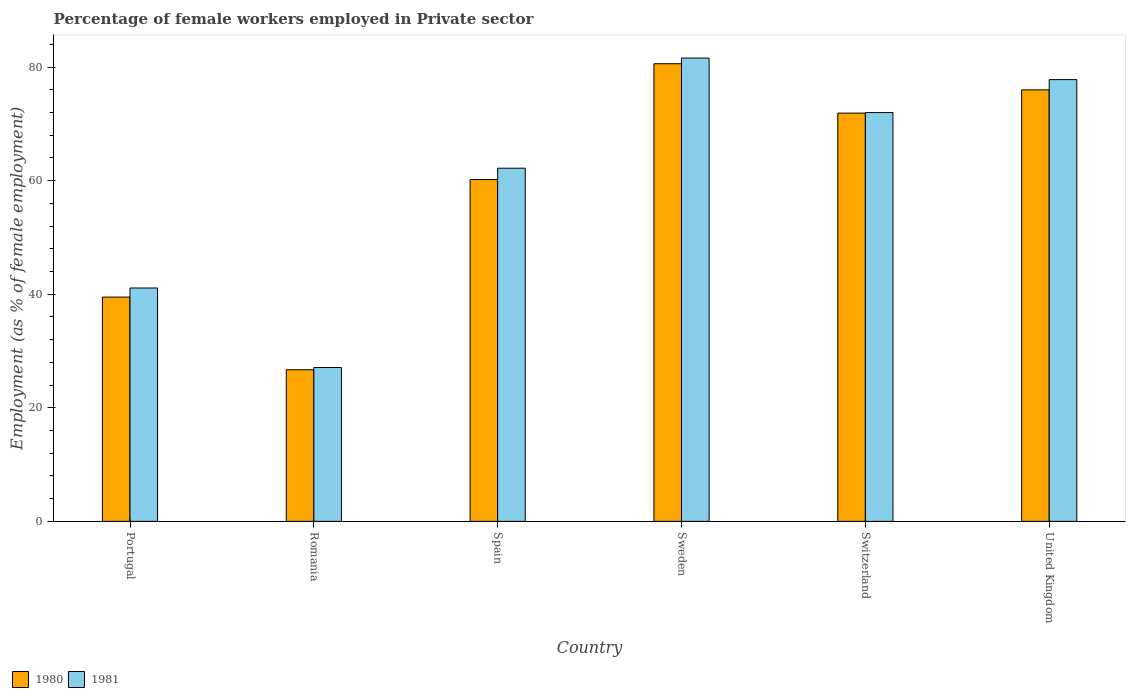How many different coloured bars are there?
Your answer should be very brief. 2. How many groups of bars are there?
Provide a succinct answer. 6. What is the label of the 6th group of bars from the left?
Give a very brief answer. United Kingdom. What is the percentage of females employed in Private sector in 1980 in Romania?
Keep it short and to the point. 26.7. Across all countries, what is the maximum percentage of females employed in Private sector in 1980?
Keep it short and to the point. 80.6. Across all countries, what is the minimum percentage of females employed in Private sector in 1981?
Ensure brevity in your answer.  27.1. In which country was the percentage of females employed in Private sector in 1981 maximum?
Ensure brevity in your answer.  Sweden. In which country was the percentage of females employed in Private sector in 1980 minimum?
Give a very brief answer. Romania. What is the total percentage of females employed in Private sector in 1981 in the graph?
Give a very brief answer. 361.8. What is the difference between the percentage of females employed in Private sector in 1981 in Romania and that in Switzerland?
Make the answer very short. -44.9. What is the difference between the percentage of females employed in Private sector in 1980 in Sweden and the percentage of females employed in Private sector in 1981 in United Kingdom?
Keep it short and to the point. 2.8. What is the average percentage of females employed in Private sector in 1980 per country?
Give a very brief answer. 59.15. What is the difference between the percentage of females employed in Private sector of/in 1981 and percentage of females employed in Private sector of/in 1980 in Switzerland?
Ensure brevity in your answer.  0.1. What is the ratio of the percentage of females employed in Private sector in 1981 in Portugal to that in Romania?
Keep it short and to the point. 1.52. What is the difference between the highest and the second highest percentage of females employed in Private sector in 1981?
Your answer should be very brief. -9.6. What is the difference between the highest and the lowest percentage of females employed in Private sector in 1981?
Give a very brief answer. 54.5. In how many countries, is the percentage of females employed in Private sector in 1981 greater than the average percentage of females employed in Private sector in 1981 taken over all countries?
Your response must be concise. 4. Is the sum of the percentage of females employed in Private sector in 1980 in Portugal and Romania greater than the maximum percentage of females employed in Private sector in 1981 across all countries?
Your answer should be compact. No. What does the 2nd bar from the left in Portugal represents?
Offer a very short reply. 1981. What does the 1st bar from the right in Spain represents?
Make the answer very short. 1981. Are the values on the major ticks of Y-axis written in scientific E-notation?
Give a very brief answer. No. Where does the legend appear in the graph?
Keep it short and to the point. Bottom left. What is the title of the graph?
Keep it short and to the point. Percentage of female workers employed in Private sector. What is the label or title of the Y-axis?
Offer a very short reply. Employment (as % of female employment). What is the Employment (as % of female employment) in 1980 in Portugal?
Offer a terse response. 39.5. What is the Employment (as % of female employment) in 1981 in Portugal?
Offer a terse response. 41.1. What is the Employment (as % of female employment) in 1980 in Romania?
Provide a succinct answer. 26.7. What is the Employment (as % of female employment) of 1981 in Romania?
Give a very brief answer. 27.1. What is the Employment (as % of female employment) of 1980 in Spain?
Your answer should be compact. 60.2. What is the Employment (as % of female employment) of 1981 in Spain?
Provide a short and direct response. 62.2. What is the Employment (as % of female employment) in 1980 in Sweden?
Your answer should be compact. 80.6. What is the Employment (as % of female employment) in 1981 in Sweden?
Your response must be concise. 81.6. What is the Employment (as % of female employment) in 1980 in Switzerland?
Ensure brevity in your answer.  71.9. What is the Employment (as % of female employment) in 1981 in Switzerland?
Make the answer very short. 72. What is the Employment (as % of female employment) in 1981 in United Kingdom?
Offer a very short reply. 77.8. Across all countries, what is the maximum Employment (as % of female employment) in 1980?
Your answer should be compact. 80.6. Across all countries, what is the maximum Employment (as % of female employment) of 1981?
Offer a very short reply. 81.6. Across all countries, what is the minimum Employment (as % of female employment) of 1980?
Your response must be concise. 26.7. Across all countries, what is the minimum Employment (as % of female employment) in 1981?
Make the answer very short. 27.1. What is the total Employment (as % of female employment) in 1980 in the graph?
Provide a short and direct response. 354.9. What is the total Employment (as % of female employment) in 1981 in the graph?
Ensure brevity in your answer.  361.8. What is the difference between the Employment (as % of female employment) of 1980 in Portugal and that in Romania?
Your answer should be compact. 12.8. What is the difference between the Employment (as % of female employment) of 1981 in Portugal and that in Romania?
Give a very brief answer. 14. What is the difference between the Employment (as % of female employment) of 1980 in Portugal and that in Spain?
Ensure brevity in your answer.  -20.7. What is the difference between the Employment (as % of female employment) of 1981 in Portugal and that in Spain?
Your answer should be compact. -21.1. What is the difference between the Employment (as % of female employment) of 1980 in Portugal and that in Sweden?
Ensure brevity in your answer.  -41.1. What is the difference between the Employment (as % of female employment) in 1981 in Portugal and that in Sweden?
Provide a succinct answer. -40.5. What is the difference between the Employment (as % of female employment) of 1980 in Portugal and that in Switzerland?
Give a very brief answer. -32.4. What is the difference between the Employment (as % of female employment) in 1981 in Portugal and that in Switzerland?
Offer a terse response. -30.9. What is the difference between the Employment (as % of female employment) in 1980 in Portugal and that in United Kingdom?
Give a very brief answer. -36.5. What is the difference between the Employment (as % of female employment) of 1981 in Portugal and that in United Kingdom?
Offer a terse response. -36.7. What is the difference between the Employment (as % of female employment) of 1980 in Romania and that in Spain?
Ensure brevity in your answer.  -33.5. What is the difference between the Employment (as % of female employment) in 1981 in Romania and that in Spain?
Give a very brief answer. -35.1. What is the difference between the Employment (as % of female employment) in 1980 in Romania and that in Sweden?
Provide a short and direct response. -53.9. What is the difference between the Employment (as % of female employment) in 1981 in Romania and that in Sweden?
Offer a terse response. -54.5. What is the difference between the Employment (as % of female employment) of 1980 in Romania and that in Switzerland?
Make the answer very short. -45.2. What is the difference between the Employment (as % of female employment) of 1981 in Romania and that in Switzerland?
Offer a terse response. -44.9. What is the difference between the Employment (as % of female employment) of 1980 in Romania and that in United Kingdom?
Your answer should be very brief. -49.3. What is the difference between the Employment (as % of female employment) in 1981 in Romania and that in United Kingdom?
Give a very brief answer. -50.7. What is the difference between the Employment (as % of female employment) in 1980 in Spain and that in Sweden?
Your answer should be very brief. -20.4. What is the difference between the Employment (as % of female employment) in 1981 in Spain and that in Sweden?
Provide a short and direct response. -19.4. What is the difference between the Employment (as % of female employment) in 1981 in Spain and that in Switzerland?
Give a very brief answer. -9.8. What is the difference between the Employment (as % of female employment) of 1980 in Spain and that in United Kingdom?
Give a very brief answer. -15.8. What is the difference between the Employment (as % of female employment) in 1981 in Spain and that in United Kingdom?
Offer a very short reply. -15.6. What is the difference between the Employment (as % of female employment) in 1980 in Sweden and that in Switzerland?
Make the answer very short. 8.7. What is the difference between the Employment (as % of female employment) of 1981 in Sweden and that in Switzerland?
Offer a very short reply. 9.6. What is the difference between the Employment (as % of female employment) of 1980 in Switzerland and that in United Kingdom?
Offer a very short reply. -4.1. What is the difference between the Employment (as % of female employment) of 1981 in Switzerland and that in United Kingdom?
Your answer should be compact. -5.8. What is the difference between the Employment (as % of female employment) in 1980 in Portugal and the Employment (as % of female employment) in 1981 in Romania?
Provide a succinct answer. 12.4. What is the difference between the Employment (as % of female employment) in 1980 in Portugal and the Employment (as % of female employment) in 1981 in Spain?
Your response must be concise. -22.7. What is the difference between the Employment (as % of female employment) in 1980 in Portugal and the Employment (as % of female employment) in 1981 in Sweden?
Ensure brevity in your answer.  -42.1. What is the difference between the Employment (as % of female employment) in 1980 in Portugal and the Employment (as % of female employment) in 1981 in Switzerland?
Your response must be concise. -32.5. What is the difference between the Employment (as % of female employment) in 1980 in Portugal and the Employment (as % of female employment) in 1981 in United Kingdom?
Ensure brevity in your answer.  -38.3. What is the difference between the Employment (as % of female employment) in 1980 in Romania and the Employment (as % of female employment) in 1981 in Spain?
Offer a terse response. -35.5. What is the difference between the Employment (as % of female employment) of 1980 in Romania and the Employment (as % of female employment) of 1981 in Sweden?
Your answer should be compact. -54.9. What is the difference between the Employment (as % of female employment) in 1980 in Romania and the Employment (as % of female employment) in 1981 in Switzerland?
Provide a succinct answer. -45.3. What is the difference between the Employment (as % of female employment) of 1980 in Romania and the Employment (as % of female employment) of 1981 in United Kingdom?
Provide a short and direct response. -51.1. What is the difference between the Employment (as % of female employment) of 1980 in Spain and the Employment (as % of female employment) of 1981 in Sweden?
Make the answer very short. -21.4. What is the difference between the Employment (as % of female employment) of 1980 in Spain and the Employment (as % of female employment) of 1981 in Switzerland?
Your answer should be compact. -11.8. What is the difference between the Employment (as % of female employment) of 1980 in Spain and the Employment (as % of female employment) of 1981 in United Kingdom?
Your answer should be compact. -17.6. What is the difference between the Employment (as % of female employment) of 1980 in Sweden and the Employment (as % of female employment) of 1981 in Switzerland?
Offer a very short reply. 8.6. What is the difference between the Employment (as % of female employment) in 1980 in Switzerland and the Employment (as % of female employment) in 1981 in United Kingdom?
Your answer should be compact. -5.9. What is the average Employment (as % of female employment) in 1980 per country?
Offer a terse response. 59.15. What is the average Employment (as % of female employment) of 1981 per country?
Provide a short and direct response. 60.3. What is the difference between the Employment (as % of female employment) of 1980 and Employment (as % of female employment) of 1981 in Portugal?
Ensure brevity in your answer.  -1.6. What is the ratio of the Employment (as % of female employment) in 1980 in Portugal to that in Romania?
Provide a short and direct response. 1.48. What is the ratio of the Employment (as % of female employment) in 1981 in Portugal to that in Romania?
Provide a short and direct response. 1.52. What is the ratio of the Employment (as % of female employment) in 1980 in Portugal to that in Spain?
Make the answer very short. 0.66. What is the ratio of the Employment (as % of female employment) in 1981 in Portugal to that in Spain?
Your answer should be compact. 0.66. What is the ratio of the Employment (as % of female employment) of 1980 in Portugal to that in Sweden?
Your answer should be very brief. 0.49. What is the ratio of the Employment (as % of female employment) of 1981 in Portugal to that in Sweden?
Ensure brevity in your answer.  0.5. What is the ratio of the Employment (as % of female employment) of 1980 in Portugal to that in Switzerland?
Offer a terse response. 0.55. What is the ratio of the Employment (as % of female employment) of 1981 in Portugal to that in Switzerland?
Provide a succinct answer. 0.57. What is the ratio of the Employment (as % of female employment) of 1980 in Portugal to that in United Kingdom?
Provide a succinct answer. 0.52. What is the ratio of the Employment (as % of female employment) in 1981 in Portugal to that in United Kingdom?
Offer a very short reply. 0.53. What is the ratio of the Employment (as % of female employment) of 1980 in Romania to that in Spain?
Provide a short and direct response. 0.44. What is the ratio of the Employment (as % of female employment) of 1981 in Romania to that in Spain?
Offer a very short reply. 0.44. What is the ratio of the Employment (as % of female employment) of 1980 in Romania to that in Sweden?
Offer a very short reply. 0.33. What is the ratio of the Employment (as % of female employment) in 1981 in Romania to that in Sweden?
Offer a very short reply. 0.33. What is the ratio of the Employment (as % of female employment) in 1980 in Romania to that in Switzerland?
Your response must be concise. 0.37. What is the ratio of the Employment (as % of female employment) in 1981 in Romania to that in Switzerland?
Keep it short and to the point. 0.38. What is the ratio of the Employment (as % of female employment) of 1980 in Romania to that in United Kingdom?
Ensure brevity in your answer.  0.35. What is the ratio of the Employment (as % of female employment) in 1981 in Romania to that in United Kingdom?
Your response must be concise. 0.35. What is the ratio of the Employment (as % of female employment) of 1980 in Spain to that in Sweden?
Keep it short and to the point. 0.75. What is the ratio of the Employment (as % of female employment) of 1981 in Spain to that in Sweden?
Your answer should be compact. 0.76. What is the ratio of the Employment (as % of female employment) of 1980 in Spain to that in Switzerland?
Keep it short and to the point. 0.84. What is the ratio of the Employment (as % of female employment) of 1981 in Spain to that in Switzerland?
Offer a terse response. 0.86. What is the ratio of the Employment (as % of female employment) in 1980 in Spain to that in United Kingdom?
Your answer should be very brief. 0.79. What is the ratio of the Employment (as % of female employment) of 1981 in Spain to that in United Kingdom?
Your answer should be very brief. 0.8. What is the ratio of the Employment (as % of female employment) in 1980 in Sweden to that in Switzerland?
Give a very brief answer. 1.12. What is the ratio of the Employment (as % of female employment) of 1981 in Sweden to that in Switzerland?
Your response must be concise. 1.13. What is the ratio of the Employment (as % of female employment) of 1980 in Sweden to that in United Kingdom?
Offer a very short reply. 1.06. What is the ratio of the Employment (as % of female employment) in 1981 in Sweden to that in United Kingdom?
Keep it short and to the point. 1.05. What is the ratio of the Employment (as % of female employment) in 1980 in Switzerland to that in United Kingdom?
Keep it short and to the point. 0.95. What is the ratio of the Employment (as % of female employment) of 1981 in Switzerland to that in United Kingdom?
Your response must be concise. 0.93. What is the difference between the highest and the second highest Employment (as % of female employment) in 1980?
Offer a very short reply. 4.6. What is the difference between the highest and the lowest Employment (as % of female employment) of 1980?
Your answer should be very brief. 53.9. What is the difference between the highest and the lowest Employment (as % of female employment) in 1981?
Your answer should be compact. 54.5. 